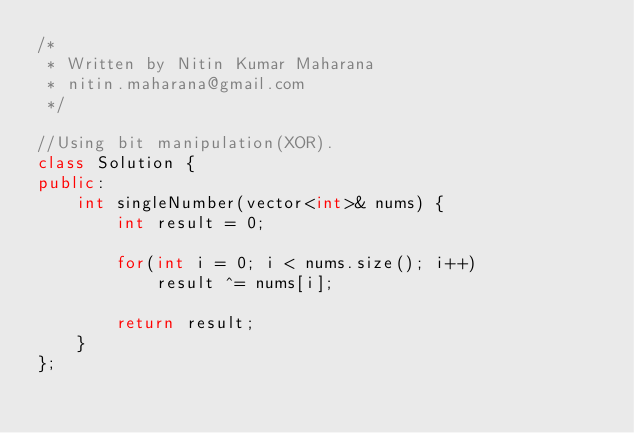Convert code to text. <code><loc_0><loc_0><loc_500><loc_500><_C++_>/*
 * Written by Nitin Kumar Maharana
 * nitin.maharana@gmail.com
 */

//Using bit manipulation(XOR).
class Solution {
public:
    int singleNumber(vector<int>& nums) {
        int result = 0;
        
        for(int i = 0; i < nums.size(); i++)
            result ^= nums[i];
        
        return result;
    }
};</code> 